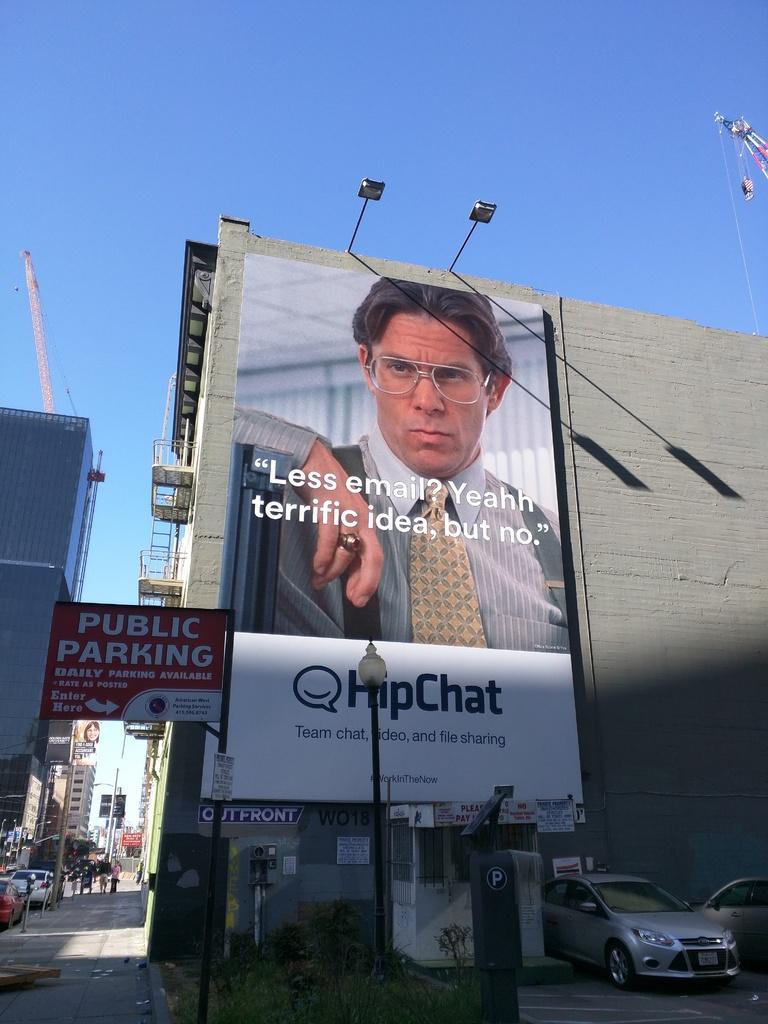Please provide a concise description of this image. In this image, we can see a poster, on that poster we can see a picture of a man, there are some cars parked, there is a black color pole, at the top there is a blue color sky. 